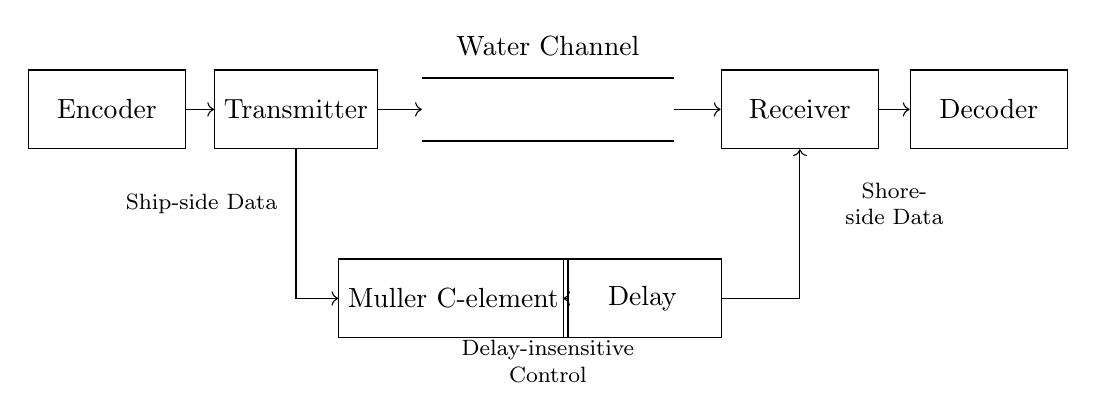What is the primary function of the encoder? The encoder's primary function is to convert the ship-side data into a format suitable for transmission.
Answer: Convert data What does the Muller C-element do in this circuit? The Muller C-element is used for delay-insensitive communication, ensuring that the signals are synchronized correctly between the ship and shore.
Answer: Synchronization How many main components are present on the ship side of the circuit? The ship side includes two main components: the encoder and the transmitter.
Answer: Two What type of communication channel is represented in this circuit? The communication channel depicted is a water channel, which indicates the medium for data transmission.
Answer: Water channel How is the transmitter connected to the Muller C-element? The transmitter is connected to the Muller C-element through a direct line, indicating that its output signals control the element.
Answer: Direct line connection What does the delay component achieve in the circuit? The delay component introduces a timing adjustment to accommodate any discrepancies from the transmission, ensuring proper synchronization at the receiver.
Answer: Timing adjustment Which component receives the data after it has passed through the receiver? After passing through the receiver, the data is sent to the decoder for interpretation and processing.
Answer: Decoder 